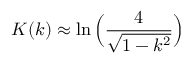<formula> <loc_0><loc_0><loc_500><loc_500>K ( k ) \approx \ln \left ( \frac { 4 } { \sqrt { 1 - k ^ { 2 } } } \right )</formula> 